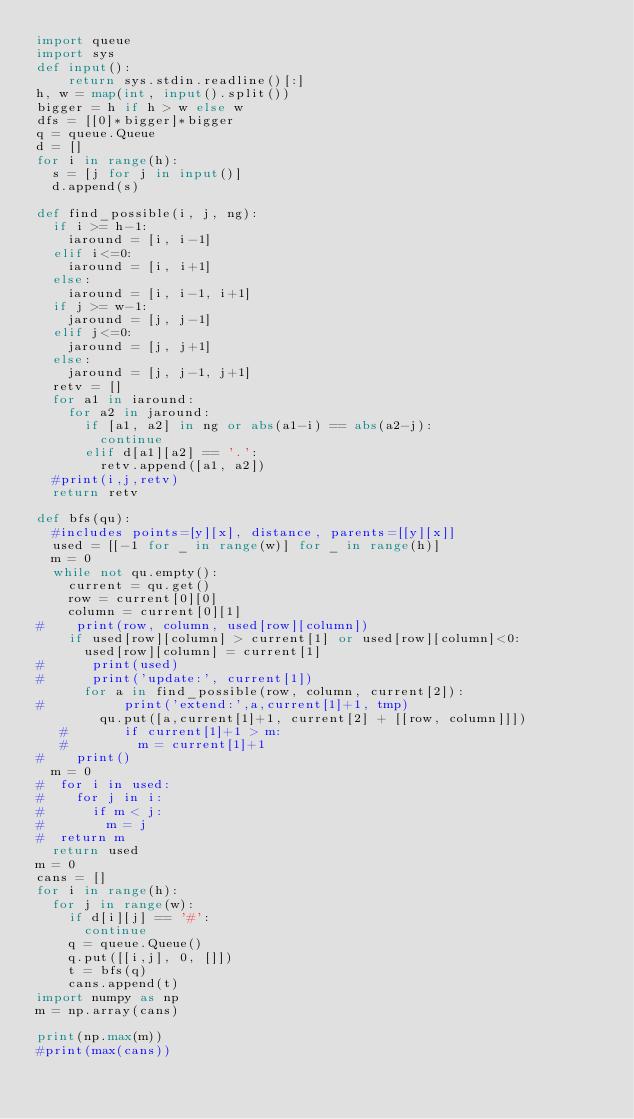<code> <loc_0><loc_0><loc_500><loc_500><_Python_>import queue
import sys
def input():
    return sys.stdin.readline()[:]
h, w = map(int, input().split())
bigger = h if h > w else w
dfs = [[0]*bigger]*bigger
q = queue.Queue
d = []
for i in range(h):
  s = [j for j in input()]
  d.append(s)

def find_possible(i, j, ng):
  if i >= h-1:
    iaround = [i, i-1]
  elif i<=0:
    iaround = [i, i+1]
  else:
    iaround = [i, i-1, i+1]
  if j >= w-1:
    jaround = [j, j-1]
  elif j<=0:
    jaround = [j, j+1]
  else:
    jaround = [j, j-1, j+1]
  retv = []
  for a1 in iaround:
    for a2 in jaround:
      if [a1, a2] in ng or abs(a1-i) == abs(a2-j):
        continue
      elif d[a1][a2] == '.':
        retv.append([a1, a2])
  #print(i,j,retv)
  return retv

def bfs(qu):
  #includes points=[y][x], distance, parents=[[y][x]]
  used = [[-1 for _ in range(w)] for _ in range(h)]
  m = 0
  while not qu.empty():
    current = qu.get()
    row = current[0][0]
    column = current[0][1]
#    print(row, column, used[row][column])
    if used[row][column] > current[1] or used[row][column]<0:
      used[row][column] = current[1]
#      print(used)
#      print('update:', current[1])
      for a in find_possible(row, column, current[2]):
#          print('extend:',a,current[1]+1, tmp)          
        qu.put([a,current[1]+1, current[2] + [[row, column]]])
   #       if current[1]+1 > m:
   #         m = current[1]+1
#    print()
  m = 0
#  for i in used:
#    for j in i:
#      if m < j:
#        m = j
#  return m
  return used
m = 0
cans = []
for i in range(h):
  for j in range(w):
    if d[i][j] == '#':
      continue
    q = queue.Queue()
    q.put([[i,j], 0, []])
    t = bfs(q)
    cans.append(t)
import numpy as np
m = np.array(cans)

print(np.max(m))
#print(max(cans))    </code> 